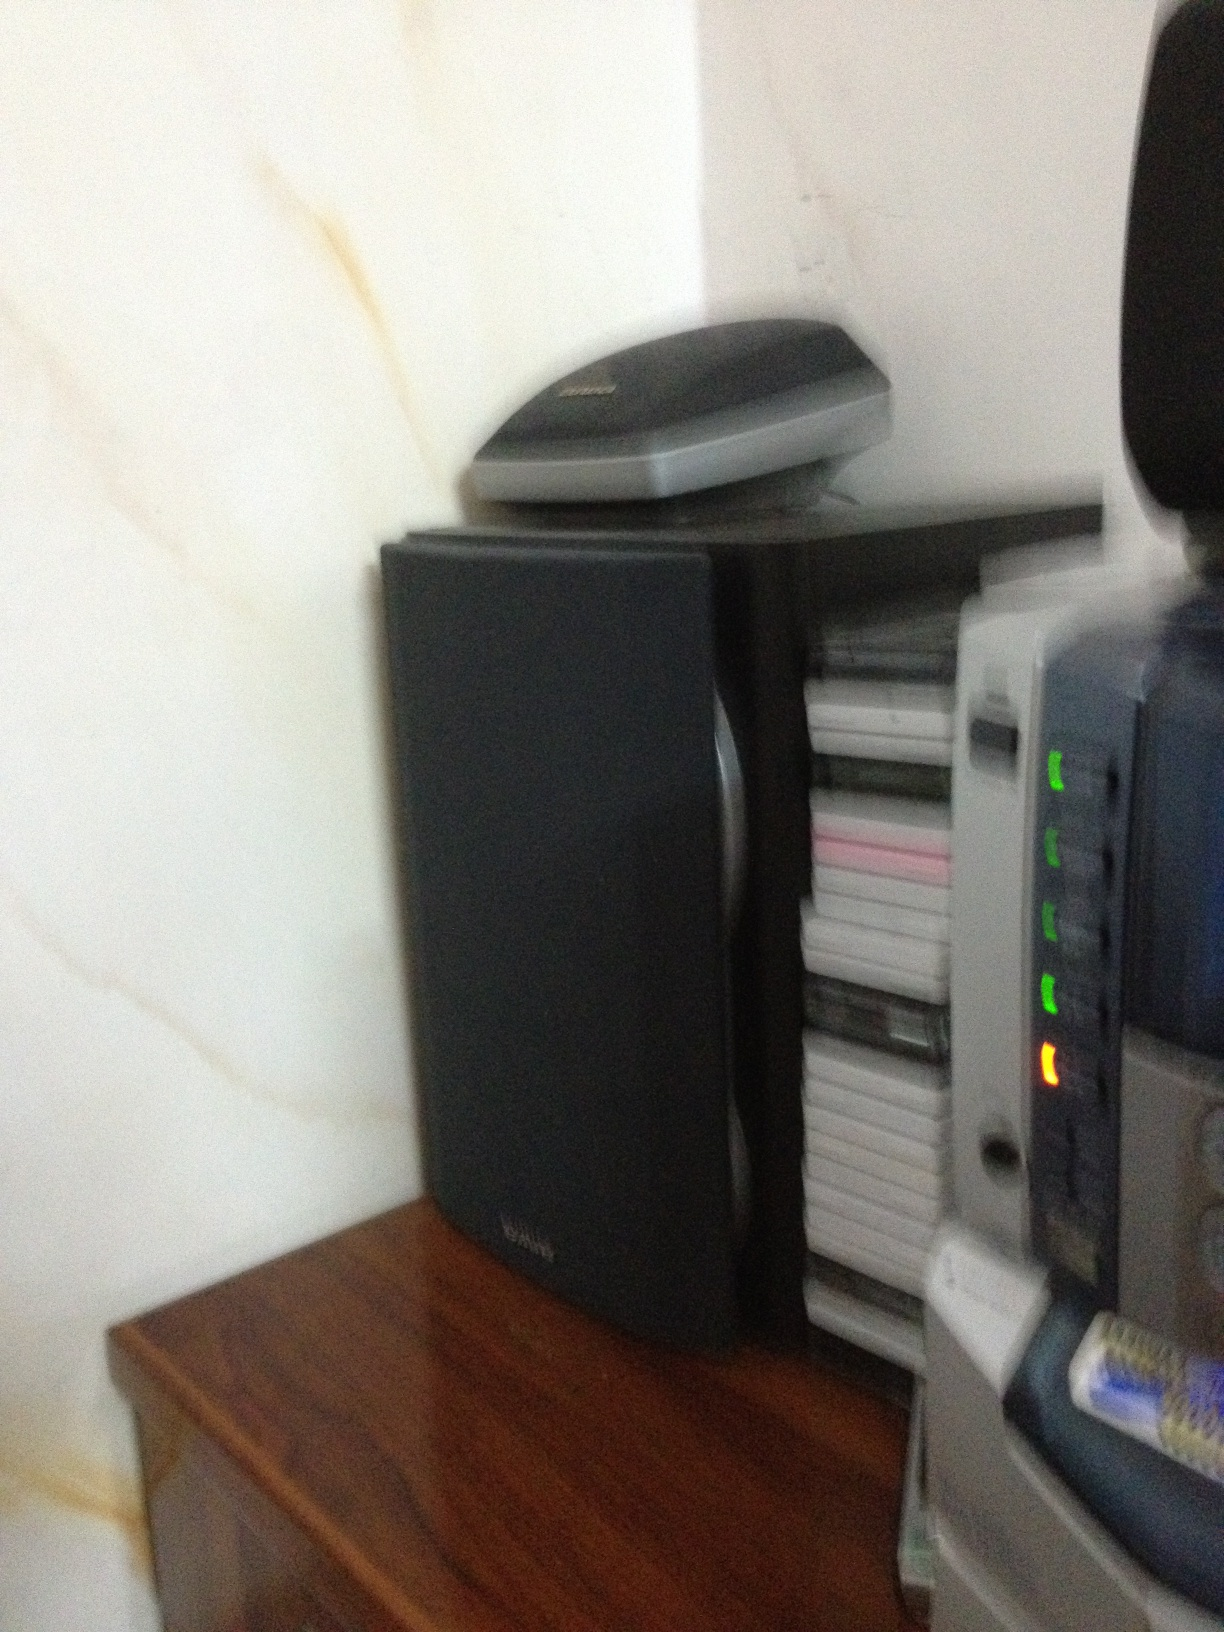Imagine this setup is part of a spaceship's control center. What are these devices used for? In a futuristic spaceship’s control center, the black speaker could serve as an advanced communication device, relaying messages and commands across the ship. The stack of CDs or DVDs transforms into high-capacity data storage discs containing crucial navigation charts, star maps, and mission logs. The flatbed scanner above the speaker becomes a multifunctional scanning device for analyzing extraterrestrial life forms and materials. The device with indicator lights on the far right operates as a central control hub, monitoring the ship's vital systems such as life support, engine performance, and defense mechanisms. It is equipped with diagnostic tools to ensure smooth operation during interstellar voyages. 